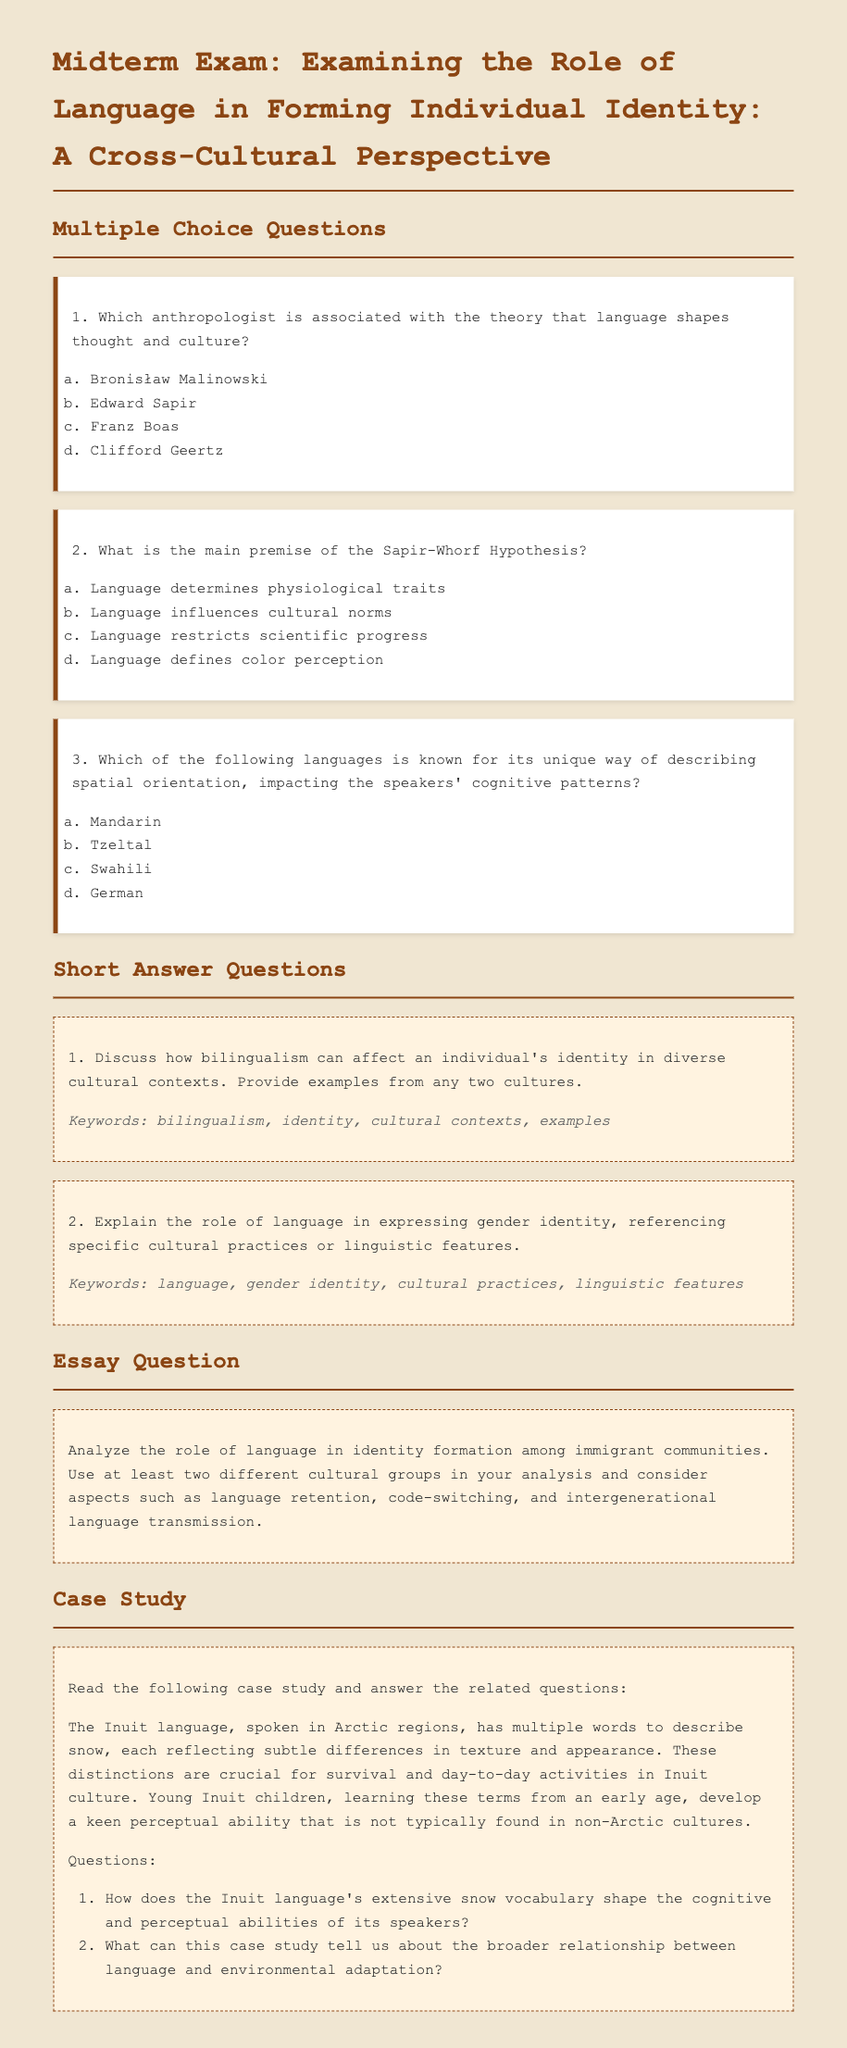What is the title of the exam? The title is stated clearly at the beginning of the document under the heading.
Answer: Midterm Exam: Examining the Role of Language in Forming Individual Identity: A Cross-Cultural Perspective Who is associated with the theory that language shapes thought and culture? This information is provided in the first multiple-choice question of the document.
Answer: Edward Sapir What is the main premise of the Sapir-Whorf Hypothesis? This information is found in the second multiple-choice question of the document.
Answer: Language influences cultural norms Which language is noted for its unique spatial orientation description? This information is explained in the third multiple-choice question in the document.
Answer: Tzeltal How many short answer questions are included in the document? The total number of short answer questions can be counted in the short answer section.
Answer: 2 What does the Inuit language's extensive snow vocabulary reflect? This information is mentioned in the case study related to how language impacts environmental understanding.
Answer: Subtle differences in texture and appearance Which type of question asks for analyzing the role of language in identity formation? The structure of the document indicates types of questions under specific sections.
Answer: Essay Question What is the purpose of the case study presented in the document? The case study aims to examine specific examples regarding the relationship between language and culture.
Answer: To illustrate the relationship between language and environmental adaptation 